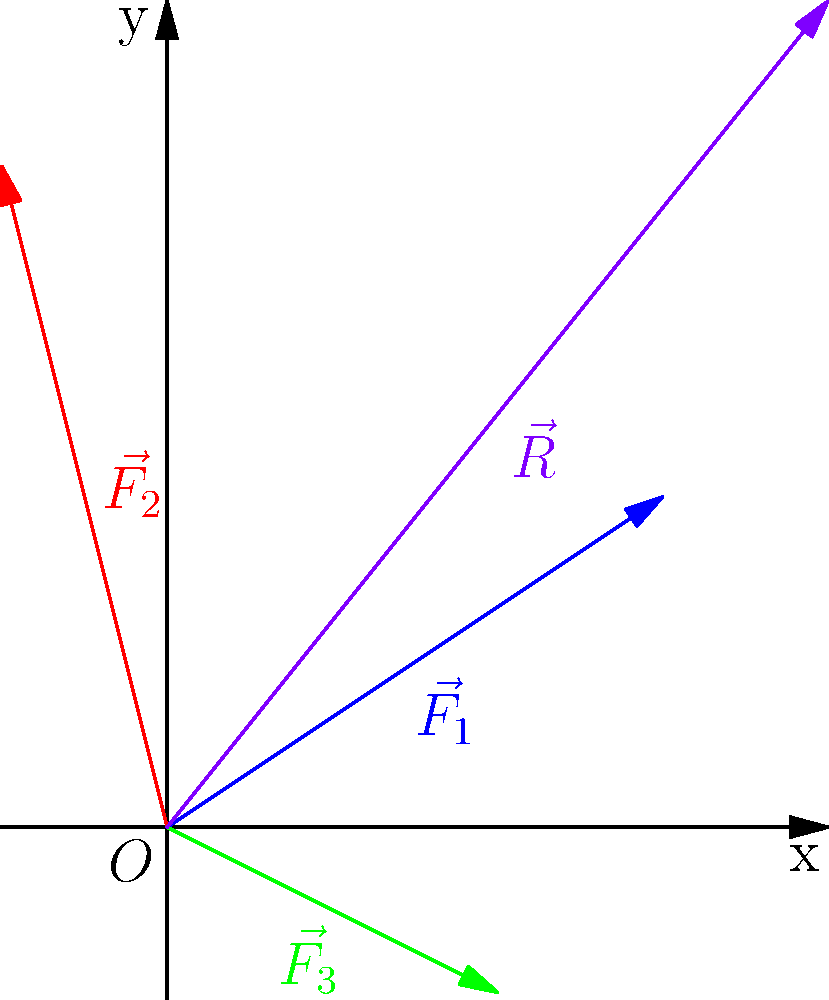During a volleyball match, a player experiences three force vectors while jumping: $\vec{F_1} = 3\hat{i} + 2\hat{j}$, $\vec{F_2} = -\hat{i} + 4\hat{j}$, and $\vec{F_3} = 2\hat{i} - \hat{j}$ (all in Newtons). Calculate the magnitude of the resultant force vector $\vec{R}$ acting on the player. To find the magnitude of the resultant force vector, we need to:

1. Add the given force vectors to find the resultant vector $\vec{R}$:
   $\vec{R} = \vec{F_1} + \vec{F_2} + \vec{F_3}$
   
2. Calculate the x and y components of $\vec{R}$:
   $R_x = 3 + (-1) + 2 = 4$ N
   $R_y = 2 + 4 + (-1) = 5$ N
   
3. Express $\vec{R}$ in component form:
   $\vec{R} = 4\hat{i} + 5\hat{j}$ N

4. Calculate the magnitude of $\vec{R}$ using the Pythagorean theorem:
   $|\vec{R}| = \sqrt{R_x^2 + R_y^2} = \sqrt{4^2 + 5^2} = \sqrt{16 + 25} = \sqrt{41}$ N

Therefore, the magnitude of the resultant force vector is $\sqrt{41}$ N.
Answer: $\sqrt{41}$ N 